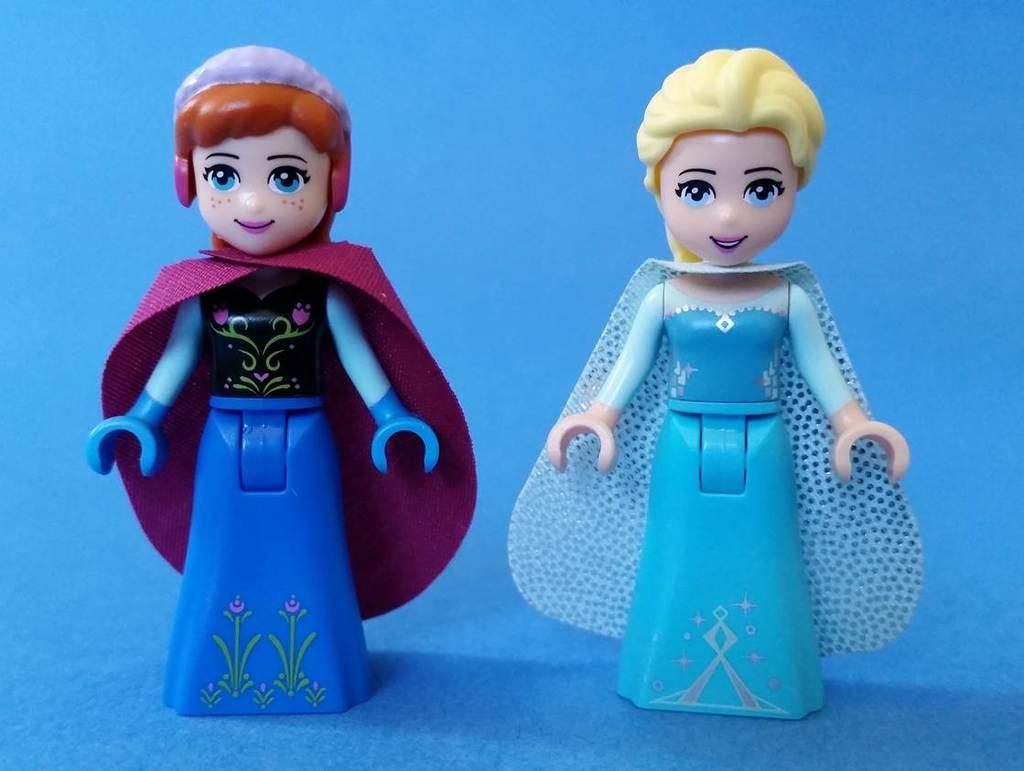How many toys are present in the image? There are two toys in the image. What is the color of the surface on which the toys are placed? The toys are on a blue surface. What type of powder is being used to clean the vase in the image? There is no vase or powder present in the image; it only features two toys on a blue surface. 